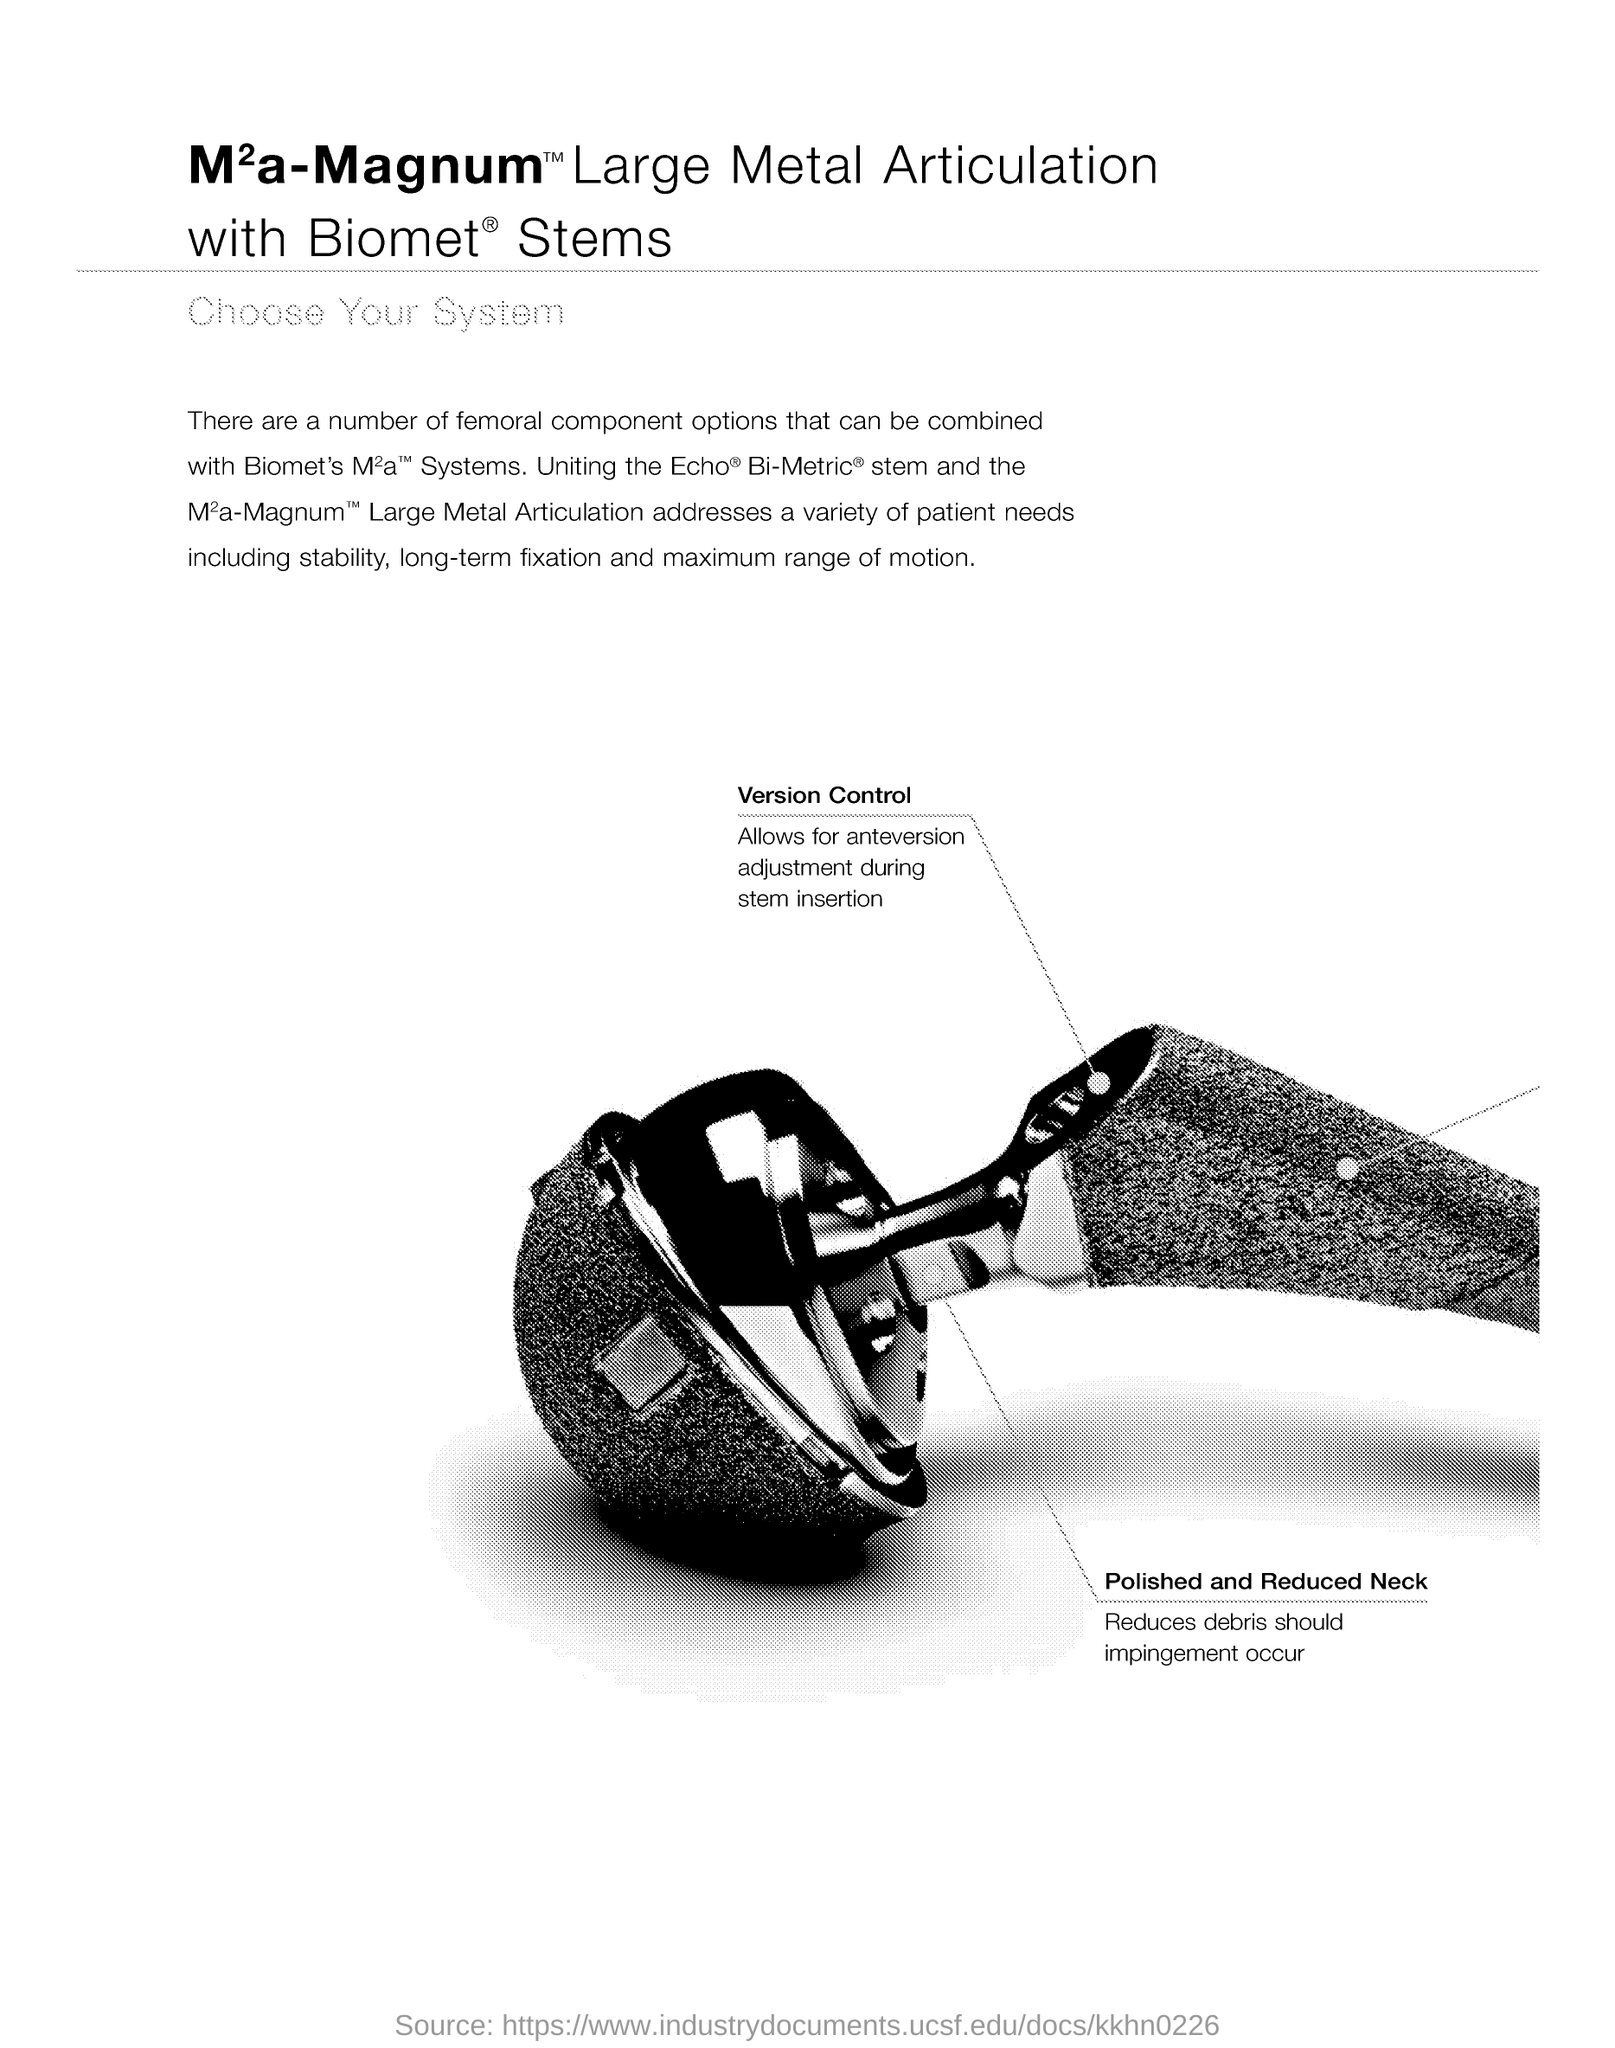Outline some significant characteristics in this image. The purpose of polished and reduced neck is to minimize debris accumulation in case of impingement, which can potentially cause damage to the system. A polished and reduced neck is preferred for reducing debris in the event of impingement. The femoral component specified in the document is designed to address a variety of patient needs, including stability, long-term fixation, and maximum range of motion, as mentioned in the document. The ability to make adjustments for anteversion during stem insertion is facilitated by version control. 